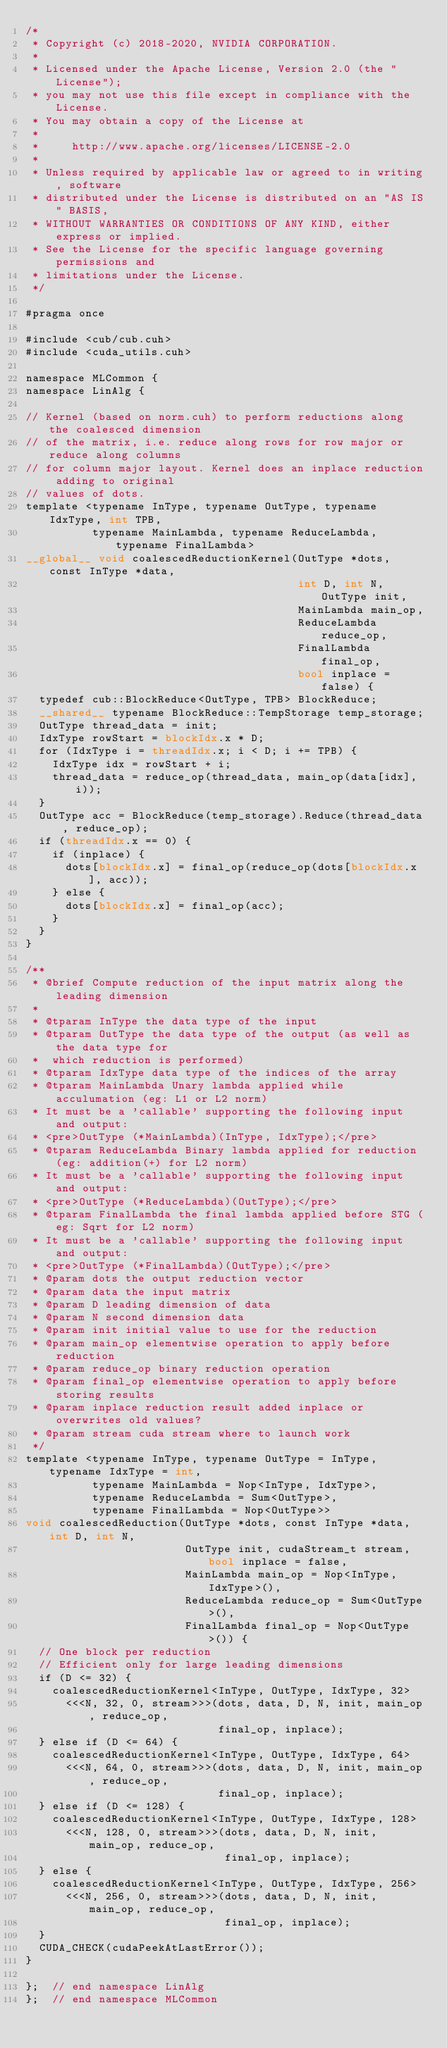<code> <loc_0><loc_0><loc_500><loc_500><_Cuda_>/*
 * Copyright (c) 2018-2020, NVIDIA CORPORATION.
 *
 * Licensed under the Apache License, Version 2.0 (the "License");
 * you may not use this file except in compliance with the License.
 * You may obtain a copy of the License at
 *
 *     http://www.apache.org/licenses/LICENSE-2.0
 *
 * Unless required by applicable law or agreed to in writing, software
 * distributed under the License is distributed on an "AS IS" BASIS,
 * WITHOUT WARRANTIES OR CONDITIONS OF ANY KIND, either express or implied.
 * See the License for the specific language governing permissions and
 * limitations under the License.
 */

#pragma once

#include <cub/cub.cuh>
#include <cuda_utils.cuh>

namespace MLCommon {
namespace LinAlg {

// Kernel (based on norm.cuh) to perform reductions along the coalesced dimension
// of the matrix, i.e. reduce along rows for row major or reduce along columns
// for column major layout. Kernel does an inplace reduction adding to original
// values of dots.
template <typename InType, typename OutType, typename IdxType, int TPB,
          typename MainLambda, typename ReduceLambda, typename FinalLambda>
__global__ void coalescedReductionKernel(OutType *dots, const InType *data,
                                         int D, int N, OutType init,
                                         MainLambda main_op,
                                         ReduceLambda reduce_op,
                                         FinalLambda final_op,
                                         bool inplace = false) {
  typedef cub::BlockReduce<OutType, TPB> BlockReduce;
  __shared__ typename BlockReduce::TempStorage temp_storage;
  OutType thread_data = init;
  IdxType rowStart = blockIdx.x * D;
  for (IdxType i = threadIdx.x; i < D; i += TPB) {
    IdxType idx = rowStart + i;
    thread_data = reduce_op(thread_data, main_op(data[idx], i));
  }
  OutType acc = BlockReduce(temp_storage).Reduce(thread_data, reduce_op);
  if (threadIdx.x == 0) {
    if (inplace) {
      dots[blockIdx.x] = final_op(reduce_op(dots[blockIdx.x], acc));
    } else {
      dots[blockIdx.x] = final_op(acc);
    }
  }
}

/**
 * @brief Compute reduction of the input matrix along the leading dimension
 *
 * @tparam InType the data type of the input
 * @tparam OutType the data type of the output (as well as the data type for
 *  which reduction is performed)
 * @tparam IdxType data type of the indices of the array
 * @tparam MainLambda Unary lambda applied while acculumation (eg: L1 or L2 norm)
 * It must be a 'callable' supporting the following input and output:
 * <pre>OutType (*MainLambda)(InType, IdxType);</pre>
 * @tparam ReduceLambda Binary lambda applied for reduction (eg: addition(+) for L2 norm)
 * It must be a 'callable' supporting the following input and output:
 * <pre>OutType (*ReduceLambda)(OutType);</pre>
 * @tparam FinalLambda the final lambda applied before STG (eg: Sqrt for L2 norm)
 * It must be a 'callable' supporting the following input and output:
 * <pre>OutType (*FinalLambda)(OutType);</pre>
 * @param dots the output reduction vector
 * @param data the input matrix
 * @param D leading dimension of data
 * @param N second dimension data
 * @param init initial value to use for the reduction
 * @param main_op elementwise operation to apply before reduction
 * @param reduce_op binary reduction operation
 * @param final_op elementwise operation to apply before storing results
 * @param inplace reduction result added inplace or overwrites old values?
 * @param stream cuda stream where to launch work
 */
template <typename InType, typename OutType = InType, typename IdxType = int,
          typename MainLambda = Nop<InType, IdxType>,
          typename ReduceLambda = Sum<OutType>,
          typename FinalLambda = Nop<OutType>>
void coalescedReduction(OutType *dots, const InType *data, int D, int N,
                        OutType init, cudaStream_t stream, bool inplace = false,
                        MainLambda main_op = Nop<InType, IdxType>(),
                        ReduceLambda reduce_op = Sum<OutType>(),
                        FinalLambda final_op = Nop<OutType>()) {
  // One block per reduction
  // Efficient only for large leading dimensions
  if (D <= 32) {
    coalescedReductionKernel<InType, OutType, IdxType, 32>
      <<<N, 32, 0, stream>>>(dots, data, D, N, init, main_op, reduce_op,
                             final_op, inplace);
  } else if (D <= 64) {
    coalescedReductionKernel<InType, OutType, IdxType, 64>
      <<<N, 64, 0, stream>>>(dots, data, D, N, init, main_op, reduce_op,
                             final_op, inplace);
  } else if (D <= 128) {
    coalescedReductionKernel<InType, OutType, IdxType, 128>
      <<<N, 128, 0, stream>>>(dots, data, D, N, init, main_op, reduce_op,
                              final_op, inplace);
  } else {
    coalescedReductionKernel<InType, OutType, IdxType, 256>
      <<<N, 256, 0, stream>>>(dots, data, D, N, init, main_op, reduce_op,
                              final_op, inplace);
  }
  CUDA_CHECK(cudaPeekAtLastError());
}

};  // end namespace LinAlg
};  // end namespace MLCommon
</code> 